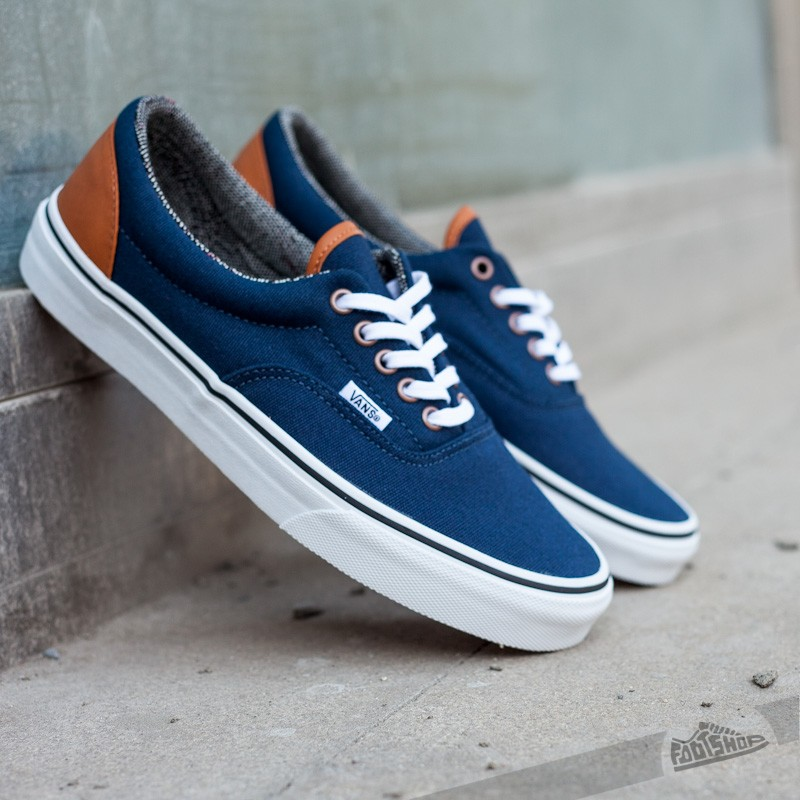Share a whimsical story about someone discovering a hidden function in these sneakers. Once upon a time, in a quaint little town, a young skateboarder named Alex stumbled upon a mysterious pair of sneakers at the local thrift store. Intrigued by their pristine condition and classic design, Alex couldn't resist buying them. Little did Alex know, these weren't ordinary sneakers. One sunny afternoon, while exploring hidden skate spots, Alex took a tumble and landed awkwardly. As Alex picked himself up, his sneakers started to glow softly. Suddenly, a holographic display appeared above them, scanning Alex's feet and adjusting to provide optimal support. Not only that, a hidden compartment within the sneakers revealed a set of tiny tools perfect for skateboard maintenance. As word of Alex's magical sneakers spread, it turned out that these enchanted shoes were part of a long-lost prototype designed by a forgotten inventor who aimed to revolutionize the skateboarding world. From that day forward, Alex's adventures were accompanied by the incredible functions of the magical sneakers, making every ride smoother and every trick more daring. 